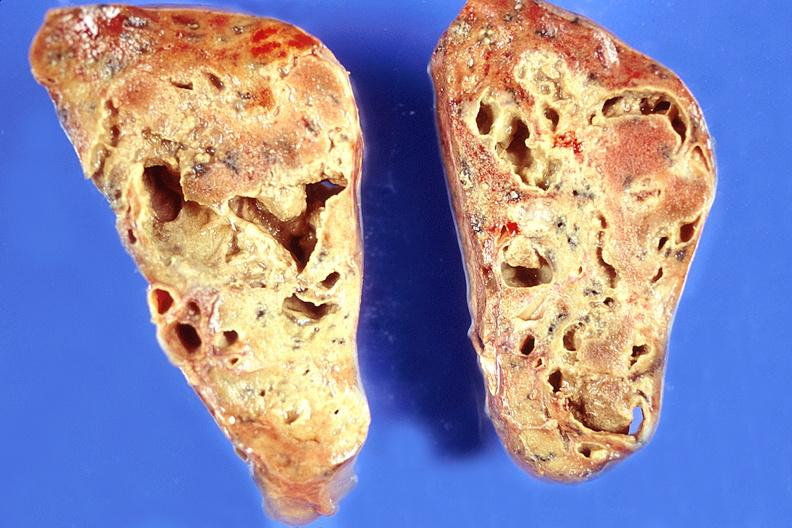what does this image show?
Answer the question using a single word or phrase. Lung 